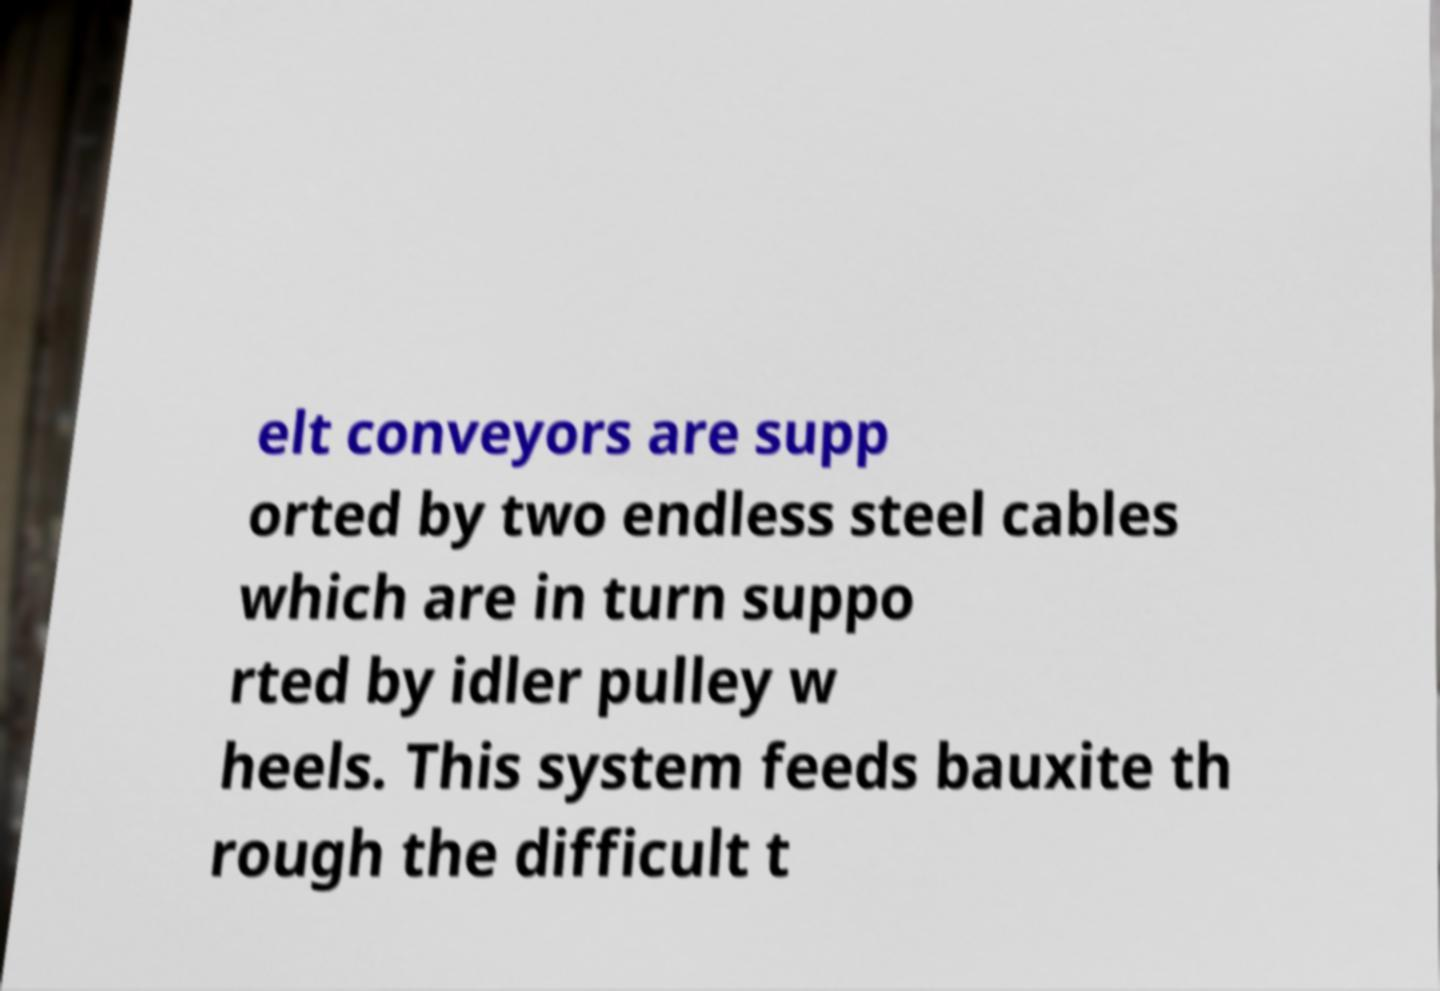Please read and relay the text visible in this image. What does it say? elt conveyors are supp orted by two endless steel cables which are in turn suppo rted by idler pulley w heels. This system feeds bauxite th rough the difficult t 